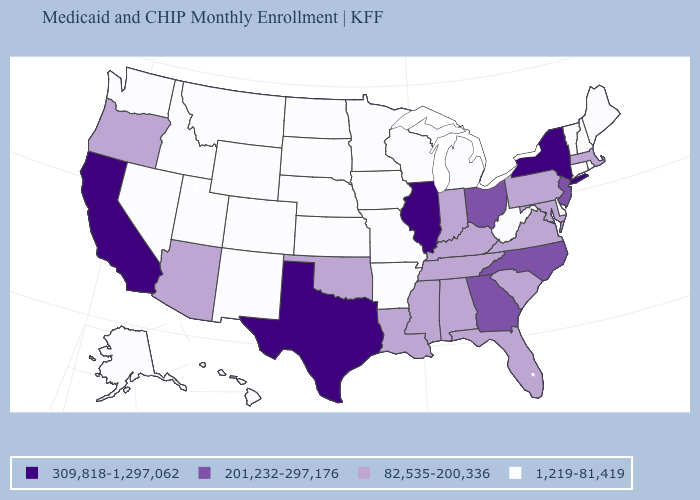What is the value of Washington?
Quick response, please. 1,219-81,419. Name the states that have a value in the range 1,219-81,419?
Concise answer only. Alaska, Arkansas, Colorado, Connecticut, Delaware, Hawaii, Idaho, Iowa, Kansas, Maine, Michigan, Minnesota, Missouri, Montana, Nebraska, Nevada, New Hampshire, New Mexico, North Dakota, Rhode Island, South Dakota, Utah, Vermont, Washington, West Virginia, Wisconsin, Wyoming. What is the value of New Jersey?
Write a very short answer. 201,232-297,176. Is the legend a continuous bar?
Keep it brief. No. Which states have the lowest value in the MidWest?
Be succinct. Iowa, Kansas, Michigan, Minnesota, Missouri, Nebraska, North Dakota, South Dakota, Wisconsin. What is the value of New Hampshire?
Give a very brief answer. 1,219-81,419. Which states have the highest value in the USA?
Answer briefly. California, Illinois, New York, Texas. Does Rhode Island have a higher value than South Carolina?
Short answer required. No. Name the states that have a value in the range 82,535-200,336?
Write a very short answer. Alabama, Arizona, Florida, Indiana, Kentucky, Louisiana, Maryland, Massachusetts, Mississippi, Oklahoma, Oregon, Pennsylvania, South Carolina, Tennessee, Virginia. Does California have the highest value in the USA?
Quick response, please. Yes. What is the lowest value in states that border North Dakota?
Short answer required. 1,219-81,419. Name the states that have a value in the range 201,232-297,176?
Keep it brief. Georgia, New Jersey, North Carolina, Ohio. Name the states that have a value in the range 82,535-200,336?
Write a very short answer. Alabama, Arizona, Florida, Indiana, Kentucky, Louisiana, Maryland, Massachusetts, Mississippi, Oklahoma, Oregon, Pennsylvania, South Carolina, Tennessee, Virginia. Among the states that border Indiana , which have the lowest value?
Give a very brief answer. Michigan. Does the first symbol in the legend represent the smallest category?
Give a very brief answer. No. 